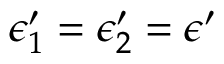Convert formula to latex. <formula><loc_0><loc_0><loc_500><loc_500>\epsilon _ { 1 } ^ { \prime } = \epsilon _ { 2 } ^ { \prime } = \epsilon ^ { \prime }</formula> 